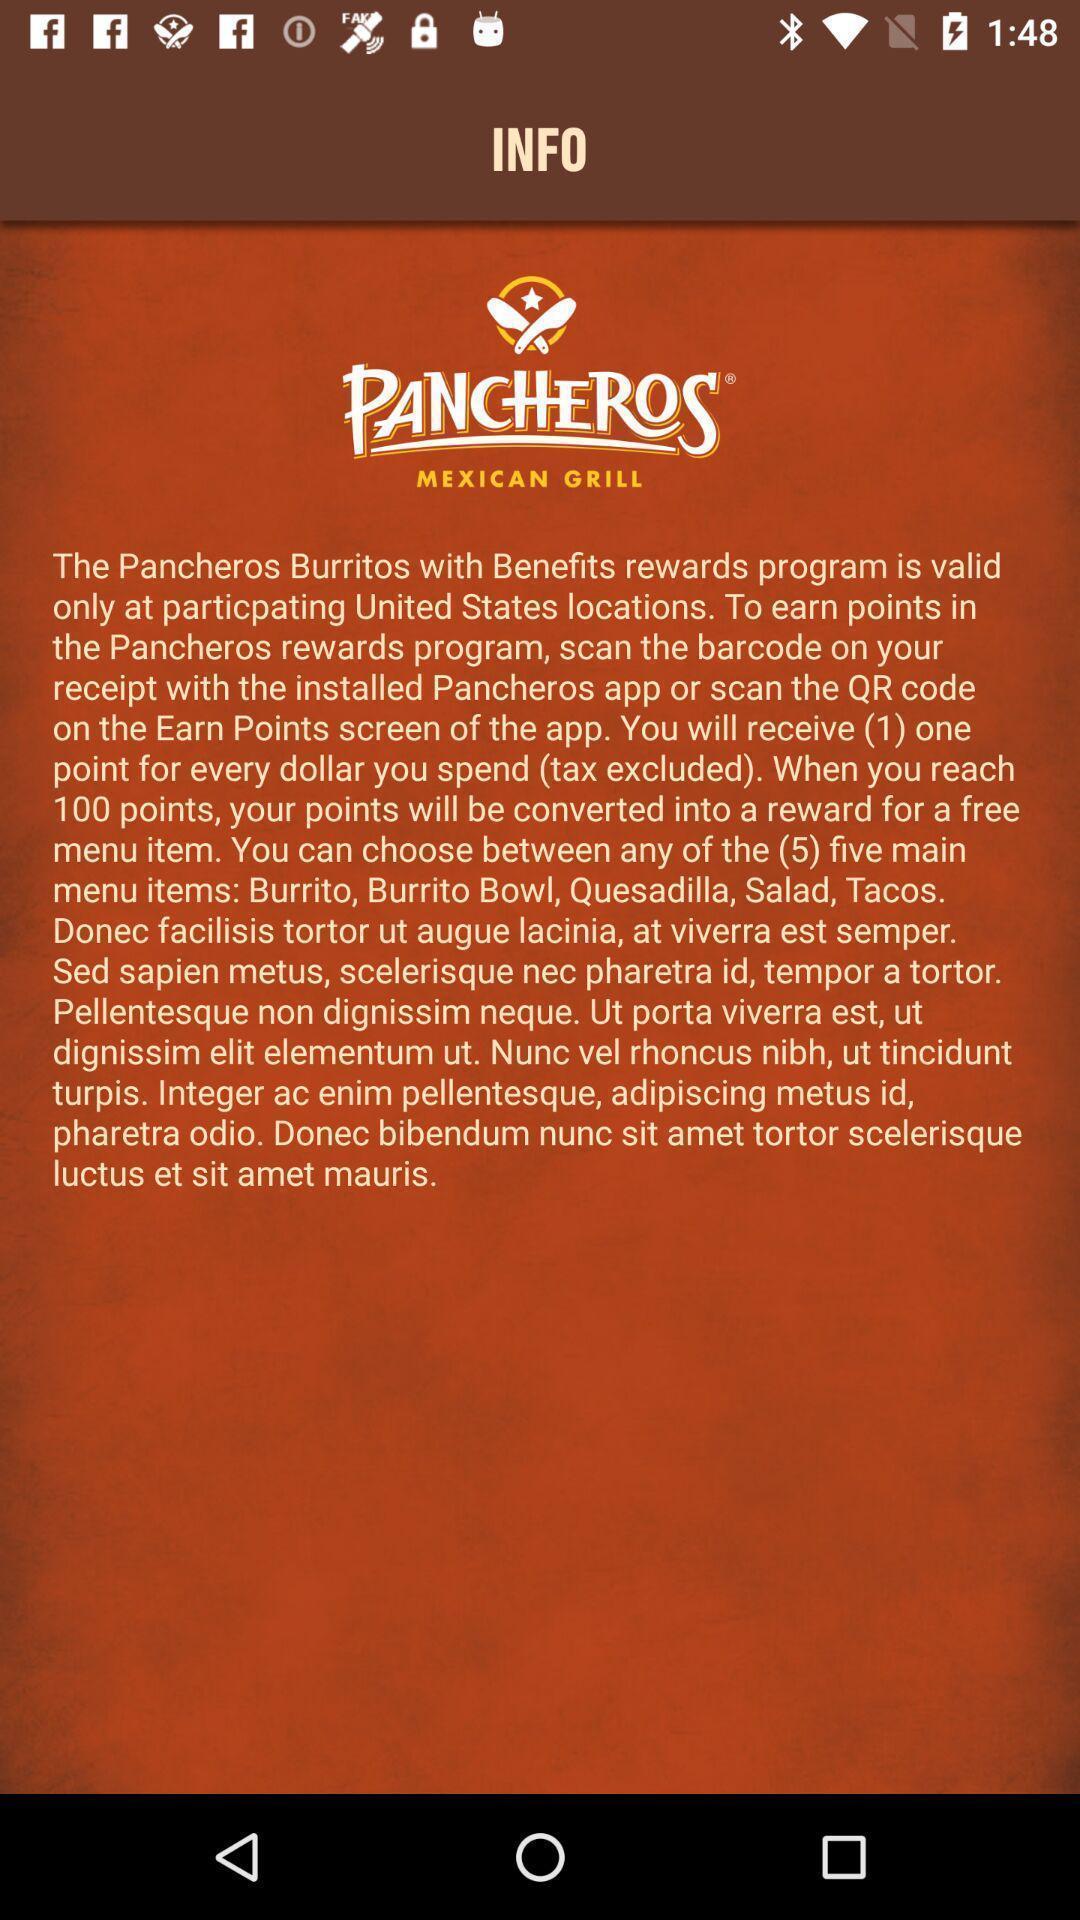Explain what's happening in this screen capture. Screen displaying information about the application. 